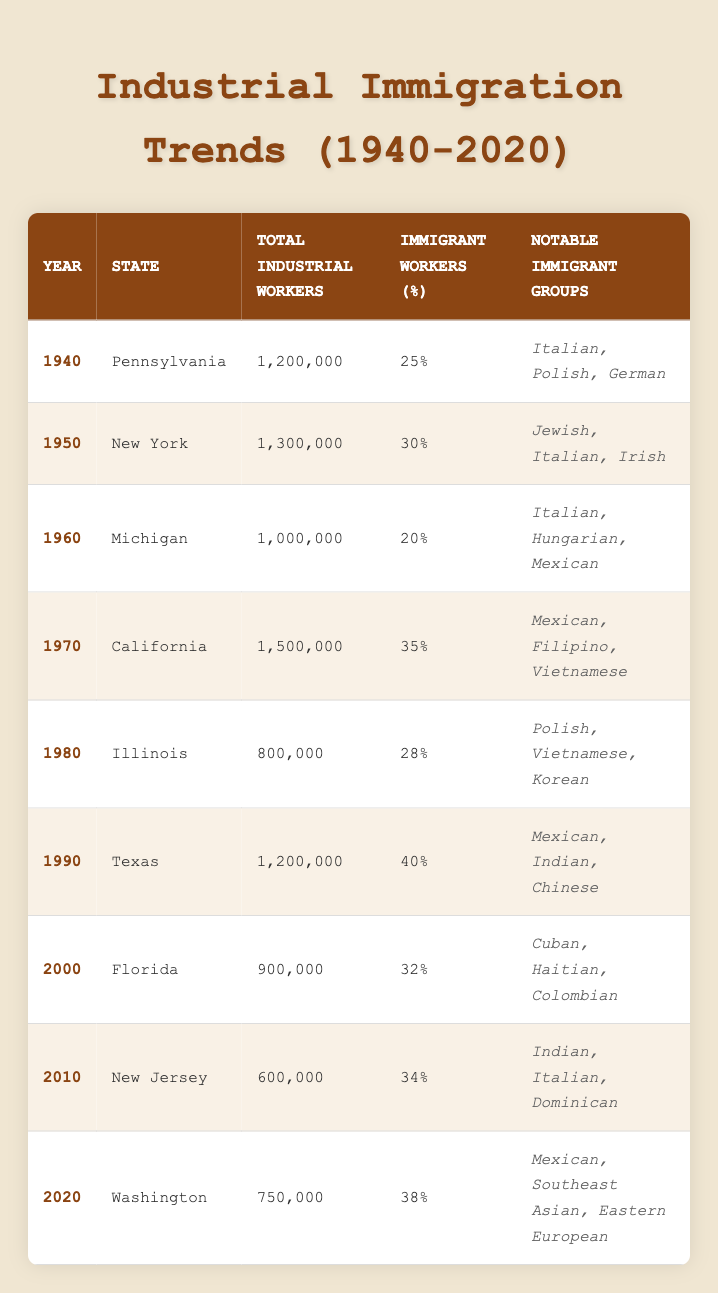What was the total number of industrial workers in New York in 1950? According to the table, the total number of industrial workers in New York in 1950 is 1,300,000.
Answer: 1,300,000 What percentage of industrial workers in Texas were immigrants in 1990? The table shows that the immigrant workers percentage in Texas in 1990 was 40%.
Answer: 40% Which state had the highest percentage of immigrant workers in the year 1970? The table indicates that California had the highest percentage of immigrant workers at 35% in 1970.
Answer: California How many total industrial workers were there across all states listed for the year 2020? The total number of industrial workers across all listed states for the year 2020 is the sum of all individual entries: 750,000 in Washington.
Answer: 750,000 Was the notable immigrant group in Illinois in 1980 mostly Polish? The table lists Polish, Vietnamese, and Korean as notable immigrant groups in Illinois in 1980, indicating that Polish was one of the groups but not exclusively. Thus, it is false that they were mostly Polish.
Answer: No What is the average percentage of immigrant workers from 1940 to 2020? The percentages of immigrant workers across the years 1940 (25), 1950 (30), 1960 (20), 1970 (35), 1980 (28), 1990 (40), 2000 (32), 2010 (34), and 2020 (38) sum up to 338. There are 9 data points. The average is 338 / 9 = 37.56, which rounds to 38%.
Answer: 38% Which year saw a decline in the total number of industrial workers compared to the previous year? Comparing the total industrial workers for successive years from the table, we find that the number declined from 900,000 in 2000 to 600,000 in 2010.
Answer: 2010 What notable immigrant groups were present in the state of Florida in the year 2000? The table specifies that the notable immigrant groups in Florida in 2000 were Cuban, Haitian, and Colombian.
Answer: Cuban, Haitian, Colombian Was the immigrant workers percentage in Michigan higher than in Illinois for the year 1980? The table shows Michigan had 20% in 1960, while Illinois in 1980 had 28%. Therefore, Illinois had a higher percentage.
Answer: No 